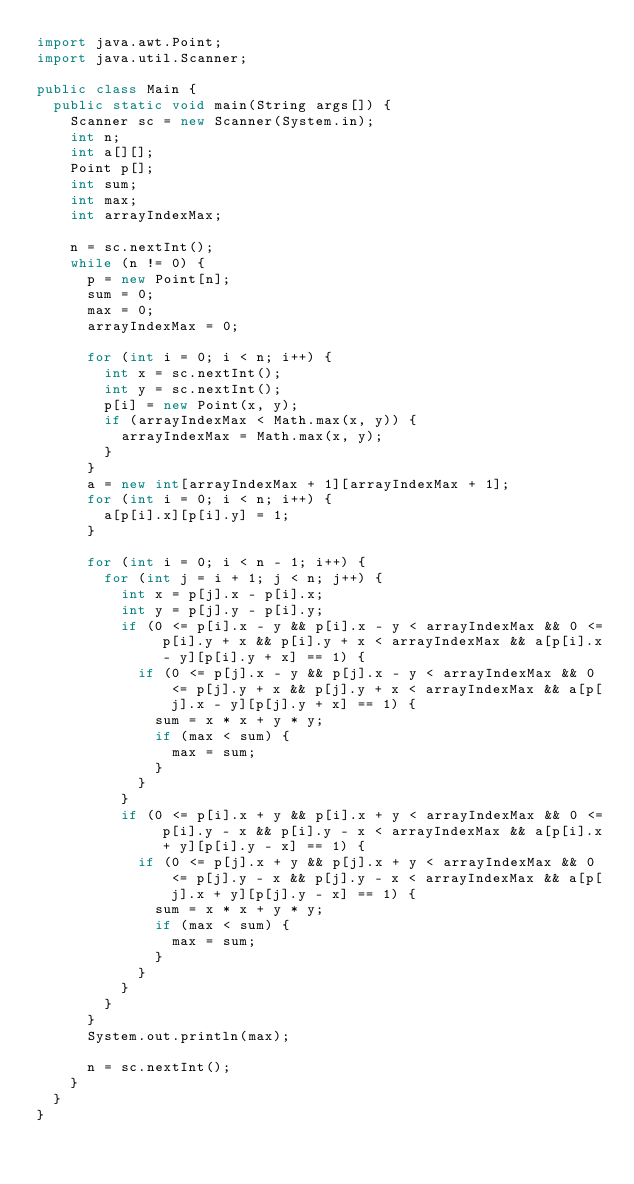<code> <loc_0><loc_0><loc_500><loc_500><_Java_>import java.awt.Point;
import java.util.Scanner;

public class Main {
	public static void main(String args[]) {
		Scanner sc = new Scanner(System.in);
		int n;
		int a[][];
		Point p[];
		int sum;
		int max;
		int arrayIndexMax;

		n = sc.nextInt();
		while (n != 0) {
			p = new Point[n];
			sum = 0;
			max = 0;
			arrayIndexMax = 0;

			for (int i = 0; i < n; i++) {
				int x = sc.nextInt();
				int y = sc.nextInt();
				p[i] = new Point(x, y);
				if (arrayIndexMax < Math.max(x, y)) {
					arrayIndexMax = Math.max(x, y);
				}
			}
			a = new int[arrayIndexMax + 1][arrayIndexMax + 1];
			for (int i = 0; i < n; i++) {
				a[p[i].x][p[i].y] = 1;
			}

			for (int i = 0; i < n - 1; i++) {
				for (int j = i + 1; j < n; j++) {
					int x = p[j].x - p[i].x;
					int y = p[j].y - p[i].y;
					if (0 <= p[i].x - y && p[i].x - y < arrayIndexMax && 0 <= p[i].y + x && p[i].y + x < arrayIndexMax && a[p[i].x - y][p[i].y + x] == 1) {
						if (0 <= p[j].x - y && p[j].x - y < arrayIndexMax && 0 <= p[j].y + x && p[j].y + x < arrayIndexMax && a[p[j].x - y][p[j].y + x] == 1) {
							sum = x * x + y * y;
							if (max < sum) {
								max = sum;
							}
						}
					}
					if (0 <= p[i].x + y && p[i].x + y < arrayIndexMax && 0 <= p[i].y - x && p[i].y - x < arrayIndexMax && a[p[i].x + y][p[i].y - x] == 1) {
						if (0 <= p[j].x + y && p[j].x + y < arrayIndexMax && 0 <= p[j].y - x && p[j].y - x < arrayIndexMax && a[p[j].x + y][p[j].y - x] == 1) {
							sum = x * x + y * y;
							if (max < sum) {
								max = sum;
							}
						}
					}
				}
			}
			System.out.println(max);

			n = sc.nextInt();
		}
	}
}</code> 